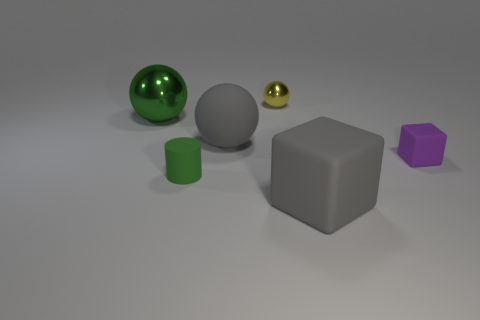What is the shape of the large shiny thing?
Make the answer very short. Sphere. Is the number of large balls to the left of the small metallic object greater than the number of purple cubes that are behind the large green sphere?
Give a very brief answer. Yes. Do the large gray rubber object in front of the tiny purple matte cube and the large rubber thing that is behind the tiny matte cylinder have the same shape?
Ensure brevity in your answer.  No. How many other things are there of the same size as the purple block?
Your answer should be very brief. 2. The green metallic thing is what size?
Your answer should be very brief. Large. Is the material of the big gray thing that is behind the small matte block the same as the tiny cube?
Provide a succinct answer. Yes. There is another metallic thing that is the same shape as the green shiny object; what color is it?
Ensure brevity in your answer.  Yellow. There is a small thing that is behind the big green thing; does it have the same color as the tiny rubber block?
Give a very brief answer. No. Are there any rubber balls right of the gray matte sphere?
Provide a short and direct response. No. There is a matte thing that is to the left of the small cube and behind the tiny green rubber cylinder; what is its color?
Make the answer very short. Gray. 